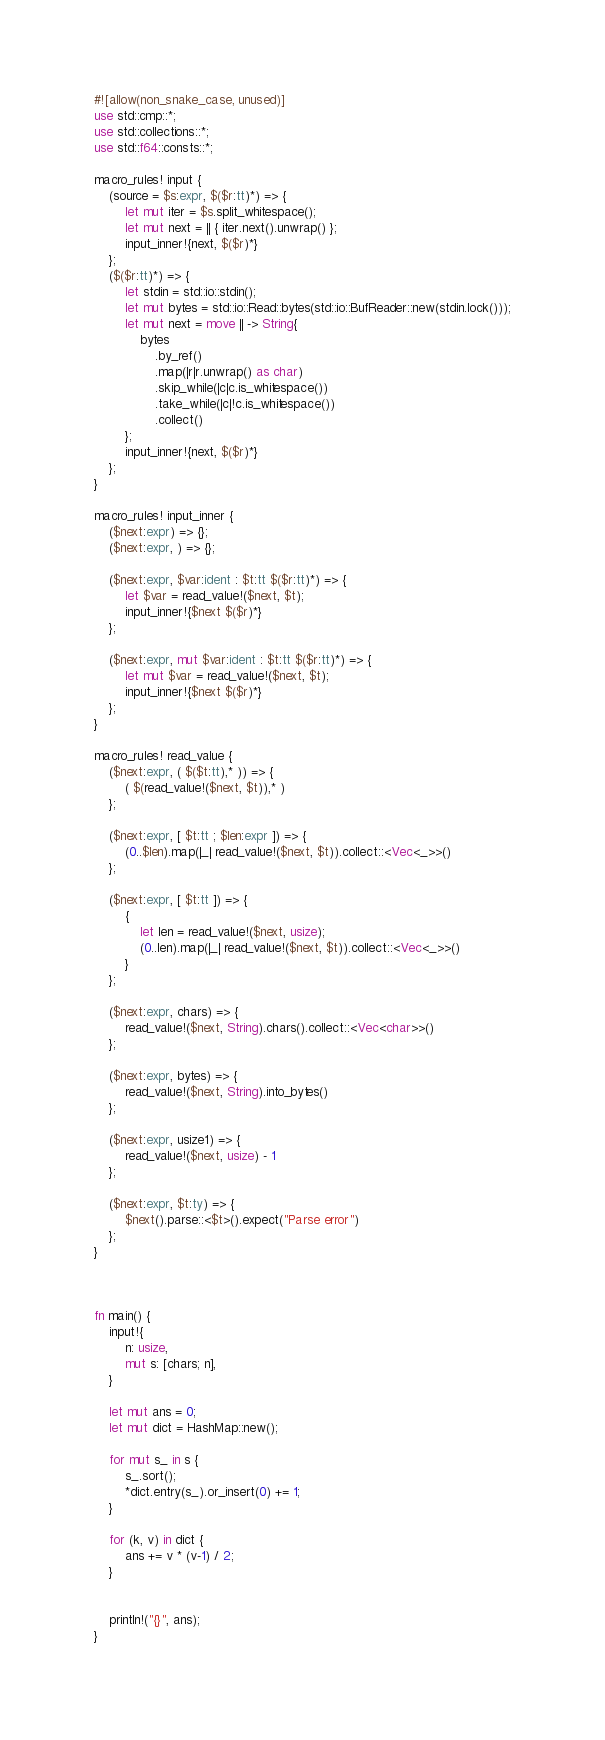Convert code to text. <code><loc_0><loc_0><loc_500><loc_500><_Rust_>#![allow(non_snake_case, unused)]
use std::cmp::*;
use std::collections::*;
use std::f64::consts::*;

macro_rules! input {
    (source = $s:expr, $($r:tt)*) => {
        let mut iter = $s.split_whitespace();
        let mut next = || { iter.next().unwrap() };
        input_inner!{next, $($r)*}
    };
    ($($r:tt)*) => {
        let stdin = std::io::stdin();
        let mut bytes = std::io::Read::bytes(std::io::BufReader::new(stdin.lock()));
        let mut next = move || -> String{
            bytes
                .by_ref()
                .map(|r|r.unwrap() as char)
                .skip_while(|c|c.is_whitespace())
                .take_while(|c|!c.is_whitespace())
                .collect()
        };
        input_inner!{next, $($r)*}
    };
}

macro_rules! input_inner {
    ($next:expr) => {};
    ($next:expr, ) => {};

    ($next:expr, $var:ident : $t:tt $($r:tt)*) => {
        let $var = read_value!($next, $t);
        input_inner!{$next $($r)*}
    };

    ($next:expr, mut $var:ident : $t:tt $($r:tt)*) => {
        let mut $var = read_value!($next, $t);
        input_inner!{$next $($r)*}
    };
}

macro_rules! read_value {
    ($next:expr, ( $($t:tt),* )) => {
        ( $(read_value!($next, $t)),* )
    };

    ($next:expr, [ $t:tt ; $len:expr ]) => {
        (0..$len).map(|_| read_value!($next, $t)).collect::<Vec<_>>()
    };

    ($next:expr, [ $t:tt ]) => {
        {
            let len = read_value!($next, usize);
            (0..len).map(|_| read_value!($next, $t)).collect::<Vec<_>>()
        }
    };

    ($next:expr, chars) => {
        read_value!($next, String).chars().collect::<Vec<char>>()
    };

    ($next:expr, bytes) => {
        read_value!($next, String).into_bytes()
    };

    ($next:expr, usize1) => {
        read_value!($next, usize) - 1
    };

    ($next:expr, $t:ty) => {
        $next().parse::<$t>().expect("Parse error")
    };
}



fn main() {
    input!{
        n: usize,
        mut s: [chars; n],
    }

    let mut ans = 0;
    let mut dict = HashMap::new();

    for mut s_ in s {
        s_.sort();
        *dict.entry(s_).or_insert(0) += 1;
    }

    for (k, v) in dict {
        ans += v * (v-1) / 2; 
    }


    println!("{}", ans);
}
</code> 